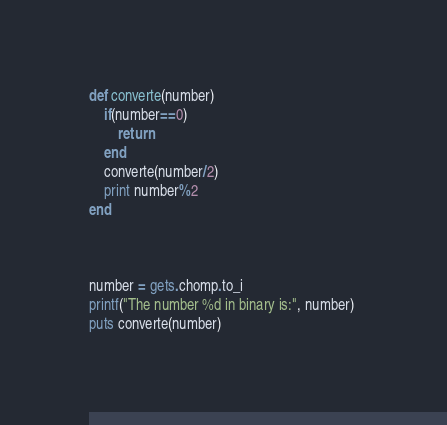Convert code to text. <code><loc_0><loc_0><loc_500><loc_500><_Ruby_>def converte(number)
	if(number==0)
		return
	end
	converte(number/2)
	print number%2
end



number = gets.chomp.to_i
printf("The number %d in binary is:", number) 
puts converte(number)

</code> 